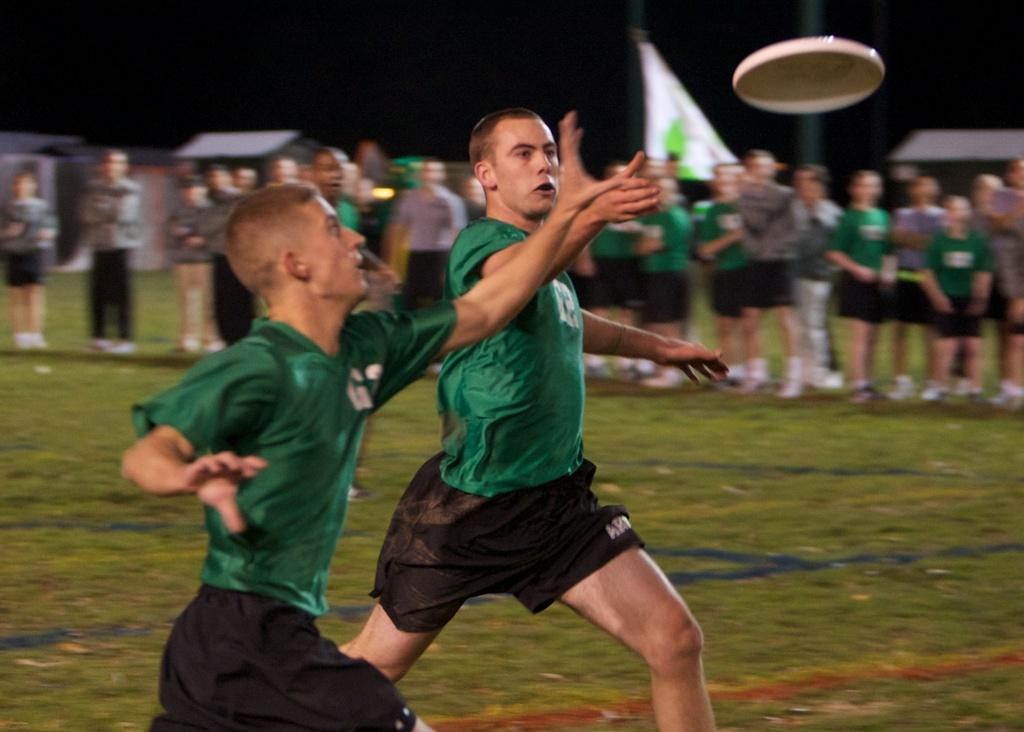What activity are the people in the image engaged in? The people in the image are playing saucer. What can be seen in the background of the image? There is a crowd and a flag visible in the background of the image. What type of structure is present in the image? There is a shed in the image. What type of terrain is visible at the bottom of the image? There is grass at the bottom of the image. Where is the bucket and faucet located in the image? There is no bucket or faucet present in the image. What type of wheel is being used by the people playing saucer in the image? The image does not show any wheels being used by the people playing saucer; they are likely using their bodies to slide on the saucer. 